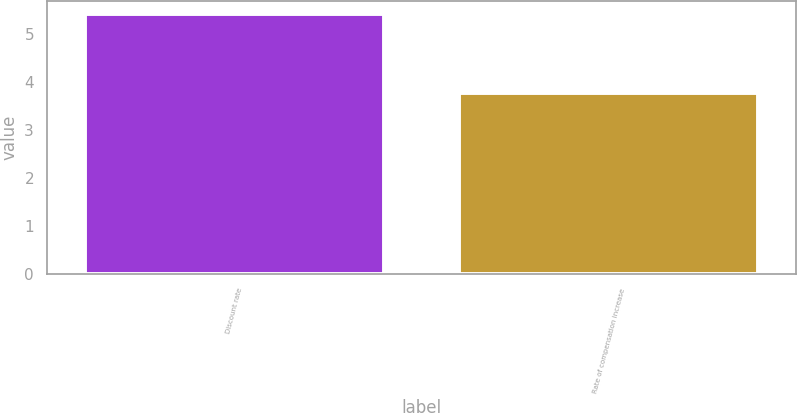<chart> <loc_0><loc_0><loc_500><loc_500><bar_chart><fcel>Discount rate<fcel>Rate of compensation increase<nl><fcel>5.41<fcel>3.76<nl></chart> 